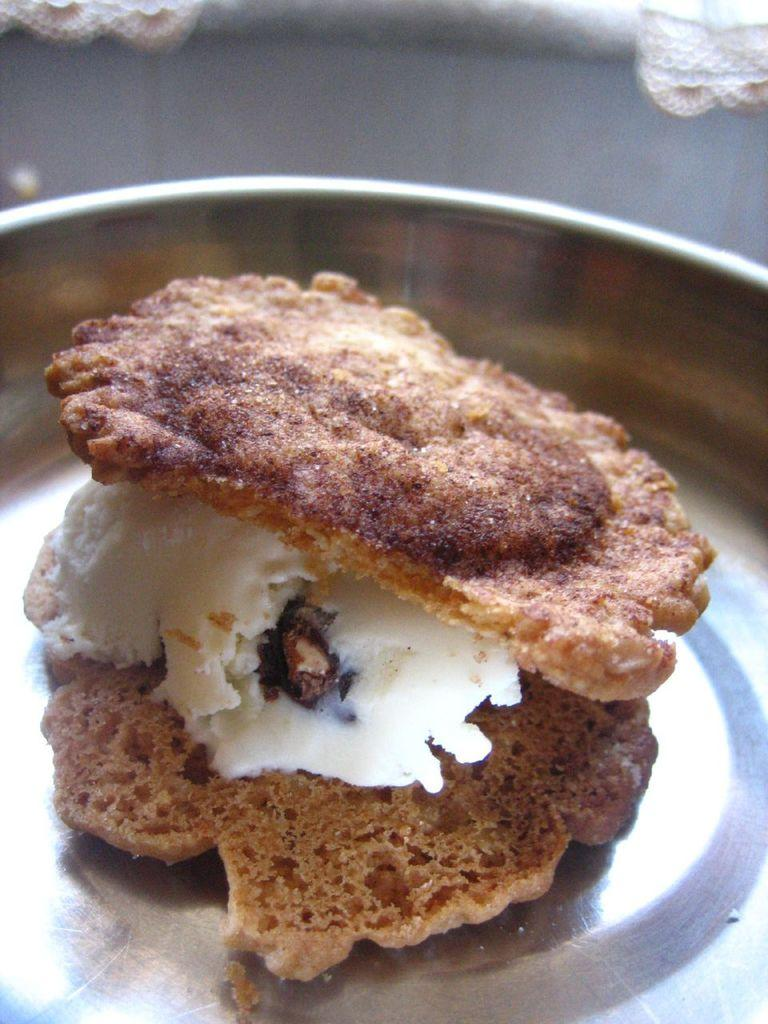What is on the plate in the image? There is food on a plate in the image. How many forks are used to pull the stocking in the image? There are no forks or stockings present in the image; it only features food on a plate. 